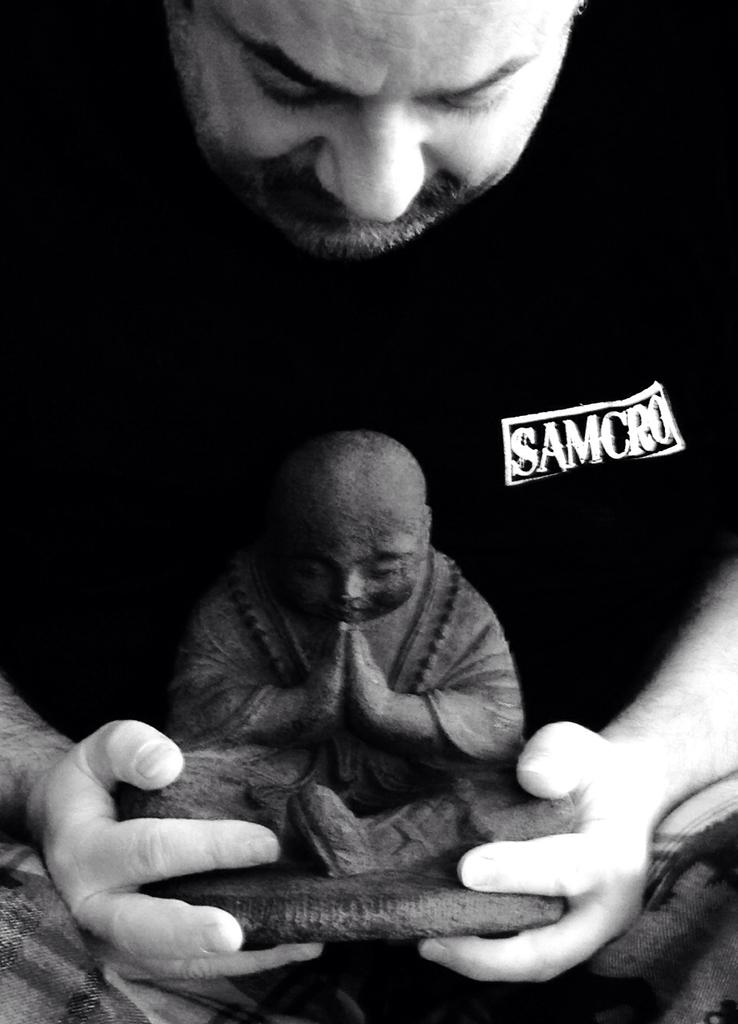What is the main subject of the image? There is a person in the image. What is the person holding in the image? The person is holding a statue. What story does the screw in the image tell? There is no screw present in the image, so there is no story to tell. 